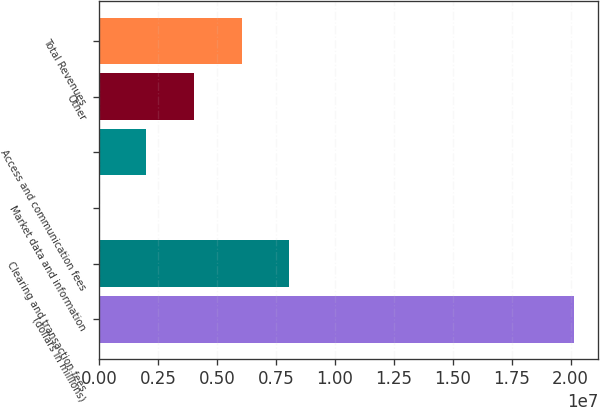Convert chart to OTSL. <chart><loc_0><loc_0><loc_500><loc_500><bar_chart><fcel>(dollars in millions)<fcel>Clearing and transaction fees<fcel>Market data and information<fcel>Access and communication fees<fcel>Other<fcel>Total Revenues<nl><fcel>2.0162e+07<fcel>8.06481e+06<fcel>2<fcel>2.0162e+06<fcel>4.0324e+06<fcel>6.04861e+06<nl></chart> 